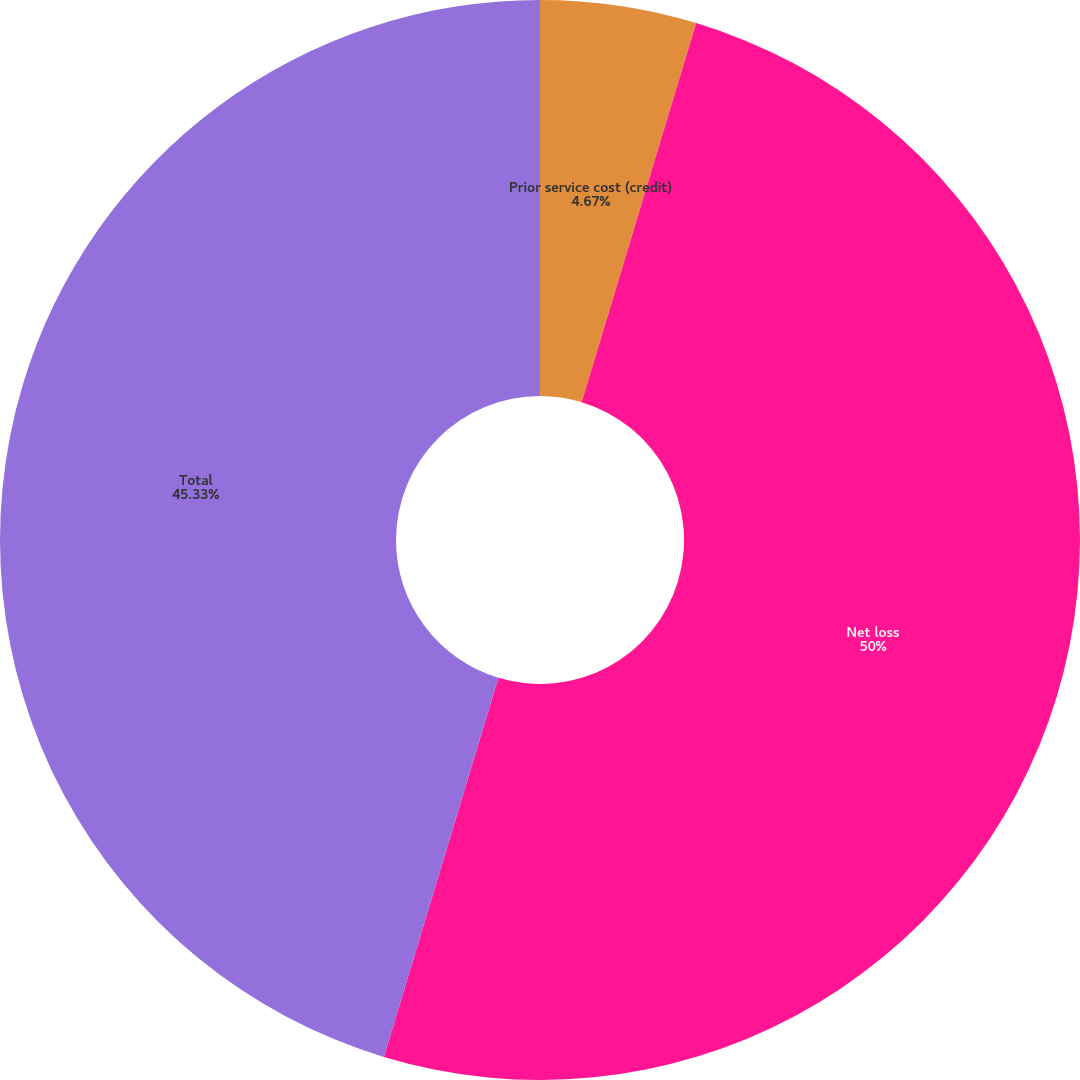Convert chart. <chart><loc_0><loc_0><loc_500><loc_500><pie_chart><fcel>Prior service cost (credit)<fcel>Net loss<fcel>Total<nl><fcel>4.67%<fcel>50.0%<fcel>45.33%<nl></chart> 